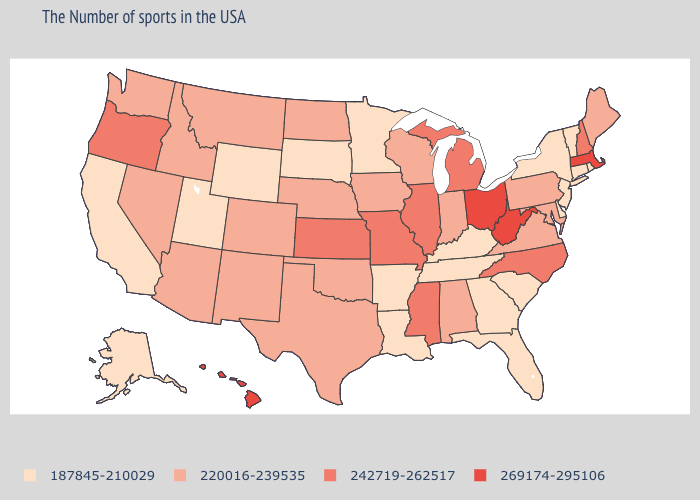What is the lowest value in states that border Texas?
Keep it brief. 187845-210029. Which states have the lowest value in the South?
Short answer required. Delaware, South Carolina, Florida, Georgia, Kentucky, Tennessee, Louisiana, Arkansas. What is the value of Kansas?
Concise answer only. 242719-262517. What is the value of Massachusetts?
Keep it brief. 269174-295106. What is the value of Delaware?
Short answer required. 187845-210029. Among the states that border Minnesota , which have the lowest value?
Give a very brief answer. South Dakota. Name the states that have a value in the range 269174-295106?
Concise answer only. Massachusetts, West Virginia, Ohio, Hawaii. Does Tennessee have the lowest value in the USA?
Keep it brief. Yes. Does Ohio have a higher value than Hawaii?
Concise answer only. No. Name the states that have a value in the range 242719-262517?
Concise answer only. New Hampshire, North Carolina, Michigan, Illinois, Mississippi, Missouri, Kansas, Oregon. Name the states that have a value in the range 269174-295106?
Keep it brief. Massachusetts, West Virginia, Ohio, Hawaii. Name the states that have a value in the range 187845-210029?
Answer briefly. Rhode Island, Vermont, Connecticut, New York, New Jersey, Delaware, South Carolina, Florida, Georgia, Kentucky, Tennessee, Louisiana, Arkansas, Minnesota, South Dakota, Wyoming, Utah, California, Alaska. Does Arkansas have the lowest value in the USA?
Answer briefly. Yes. Does the map have missing data?
Short answer required. No. Name the states that have a value in the range 220016-239535?
Be succinct. Maine, Maryland, Pennsylvania, Virginia, Indiana, Alabama, Wisconsin, Iowa, Nebraska, Oklahoma, Texas, North Dakota, Colorado, New Mexico, Montana, Arizona, Idaho, Nevada, Washington. 